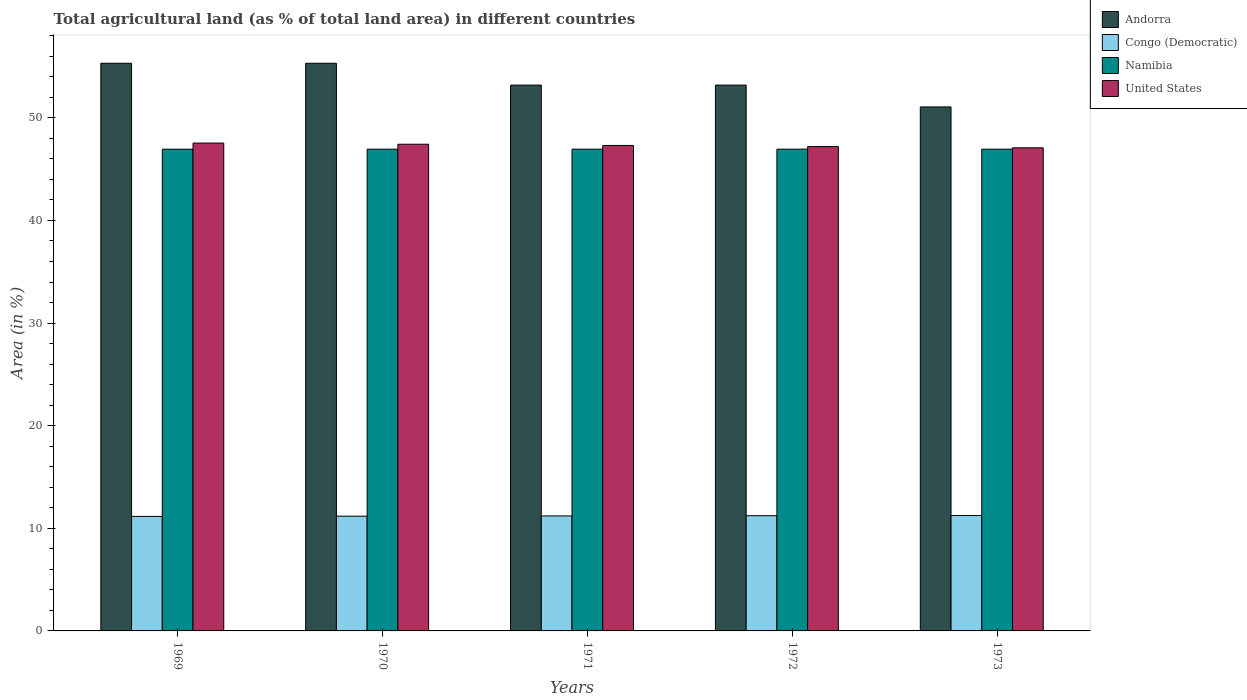How many groups of bars are there?
Your response must be concise. 5. Are the number of bars on each tick of the X-axis equal?
Offer a terse response. Yes. How many bars are there on the 1st tick from the left?
Provide a short and direct response. 4. What is the percentage of agricultural land in Andorra in 1971?
Keep it short and to the point. 53.19. Across all years, what is the maximum percentage of agricultural land in Congo (Democratic)?
Your answer should be compact. 11.25. Across all years, what is the minimum percentage of agricultural land in Congo (Democratic)?
Your answer should be compact. 11.16. In which year was the percentage of agricultural land in Andorra maximum?
Offer a very short reply. 1969. In which year was the percentage of agricultural land in Namibia minimum?
Make the answer very short. 1969. What is the total percentage of agricultural land in Congo (Democratic) in the graph?
Your response must be concise. 56.02. What is the difference between the percentage of agricultural land in Congo (Democratic) in 1969 and that in 1973?
Ensure brevity in your answer.  -0.09. What is the difference between the percentage of agricultural land in United States in 1973 and the percentage of agricultural land in Namibia in 1972?
Offer a very short reply. 0.13. What is the average percentage of agricultural land in Namibia per year?
Your answer should be compact. 46.95. In the year 1972, what is the difference between the percentage of agricultural land in Andorra and percentage of agricultural land in Namibia?
Offer a very short reply. 6.24. What is the ratio of the percentage of agricultural land in Namibia in 1969 to that in 1972?
Provide a succinct answer. 1. Is the difference between the percentage of agricultural land in Andorra in 1969 and 1970 greater than the difference between the percentage of agricultural land in Namibia in 1969 and 1970?
Ensure brevity in your answer.  Yes. What is the difference between the highest and the second highest percentage of agricultural land in United States?
Your response must be concise. 0.11. What is the difference between the highest and the lowest percentage of agricultural land in Andorra?
Offer a very short reply. 4.26. In how many years, is the percentage of agricultural land in United States greater than the average percentage of agricultural land in United States taken over all years?
Give a very brief answer. 2. What does the 1st bar from the left in 1970 represents?
Provide a short and direct response. Andorra. What does the 4th bar from the right in 1969 represents?
Provide a short and direct response. Andorra. Is it the case that in every year, the sum of the percentage of agricultural land in Namibia and percentage of agricultural land in United States is greater than the percentage of agricultural land in Andorra?
Your response must be concise. Yes. How many bars are there?
Provide a short and direct response. 20. Are all the bars in the graph horizontal?
Offer a terse response. No. How many years are there in the graph?
Your answer should be compact. 5. What is the difference between two consecutive major ticks on the Y-axis?
Keep it short and to the point. 10. Are the values on the major ticks of Y-axis written in scientific E-notation?
Your response must be concise. No. Where does the legend appear in the graph?
Keep it short and to the point. Top right. How many legend labels are there?
Offer a very short reply. 4. What is the title of the graph?
Your response must be concise. Total agricultural land (as % of total land area) in different countries. What is the label or title of the Y-axis?
Make the answer very short. Area (in %). What is the Area (in %) of Andorra in 1969?
Your response must be concise. 55.32. What is the Area (in %) in Congo (Democratic) in 1969?
Keep it short and to the point. 11.16. What is the Area (in %) of Namibia in 1969?
Your answer should be very brief. 46.94. What is the Area (in %) in United States in 1969?
Your answer should be very brief. 47.54. What is the Area (in %) in Andorra in 1970?
Your answer should be compact. 55.32. What is the Area (in %) in Congo (Democratic) in 1970?
Your response must be concise. 11.18. What is the Area (in %) of Namibia in 1970?
Keep it short and to the point. 46.95. What is the Area (in %) of United States in 1970?
Your answer should be compact. 47.43. What is the Area (in %) in Andorra in 1971?
Give a very brief answer. 53.19. What is the Area (in %) of Congo (Democratic) in 1971?
Provide a short and direct response. 11.2. What is the Area (in %) in Namibia in 1971?
Provide a succinct answer. 46.95. What is the Area (in %) of United States in 1971?
Make the answer very short. 47.31. What is the Area (in %) in Andorra in 1972?
Ensure brevity in your answer.  53.19. What is the Area (in %) in Congo (Democratic) in 1972?
Offer a very short reply. 11.23. What is the Area (in %) in Namibia in 1972?
Make the answer very short. 46.95. What is the Area (in %) in United States in 1972?
Your response must be concise. 47.2. What is the Area (in %) of Andorra in 1973?
Give a very brief answer. 51.06. What is the Area (in %) in Congo (Democratic) in 1973?
Ensure brevity in your answer.  11.25. What is the Area (in %) in Namibia in 1973?
Offer a very short reply. 46.95. What is the Area (in %) of United States in 1973?
Provide a short and direct response. 47.08. Across all years, what is the maximum Area (in %) in Andorra?
Give a very brief answer. 55.32. Across all years, what is the maximum Area (in %) of Congo (Democratic)?
Offer a terse response. 11.25. Across all years, what is the maximum Area (in %) in Namibia?
Provide a short and direct response. 46.95. Across all years, what is the maximum Area (in %) of United States?
Your answer should be compact. 47.54. Across all years, what is the minimum Area (in %) in Andorra?
Offer a very short reply. 51.06. Across all years, what is the minimum Area (in %) of Congo (Democratic)?
Make the answer very short. 11.16. Across all years, what is the minimum Area (in %) of Namibia?
Your response must be concise. 46.94. Across all years, what is the minimum Area (in %) of United States?
Ensure brevity in your answer.  47.08. What is the total Area (in %) of Andorra in the graph?
Provide a short and direct response. 268.09. What is the total Area (in %) in Congo (Democratic) in the graph?
Offer a very short reply. 56.02. What is the total Area (in %) of Namibia in the graph?
Offer a terse response. 234.74. What is the total Area (in %) of United States in the graph?
Provide a succinct answer. 236.56. What is the difference between the Area (in %) in Congo (Democratic) in 1969 and that in 1970?
Offer a terse response. -0.02. What is the difference between the Area (in %) of Namibia in 1969 and that in 1970?
Your response must be concise. -0. What is the difference between the Area (in %) in United States in 1969 and that in 1970?
Your answer should be very brief. 0.11. What is the difference between the Area (in %) of Andorra in 1969 and that in 1971?
Make the answer very short. 2.13. What is the difference between the Area (in %) of Congo (Democratic) in 1969 and that in 1971?
Offer a terse response. -0.04. What is the difference between the Area (in %) in Namibia in 1969 and that in 1971?
Make the answer very short. -0. What is the difference between the Area (in %) of United States in 1969 and that in 1971?
Offer a very short reply. 0.23. What is the difference between the Area (in %) in Andorra in 1969 and that in 1972?
Your answer should be compact. 2.13. What is the difference between the Area (in %) in Congo (Democratic) in 1969 and that in 1972?
Make the answer very short. -0.07. What is the difference between the Area (in %) in Namibia in 1969 and that in 1972?
Make the answer very short. -0. What is the difference between the Area (in %) of United States in 1969 and that in 1972?
Your answer should be compact. 0.34. What is the difference between the Area (in %) of Andorra in 1969 and that in 1973?
Offer a very short reply. 4.26. What is the difference between the Area (in %) in Congo (Democratic) in 1969 and that in 1973?
Make the answer very short. -0.09. What is the difference between the Area (in %) in Namibia in 1969 and that in 1973?
Your response must be concise. -0. What is the difference between the Area (in %) of United States in 1969 and that in 1973?
Ensure brevity in your answer.  0.46. What is the difference between the Area (in %) in Andorra in 1970 and that in 1971?
Provide a short and direct response. 2.13. What is the difference between the Area (in %) of Congo (Democratic) in 1970 and that in 1971?
Provide a short and direct response. -0.02. What is the difference between the Area (in %) of Namibia in 1970 and that in 1971?
Provide a short and direct response. -0. What is the difference between the Area (in %) of United States in 1970 and that in 1971?
Ensure brevity in your answer.  0.12. What is the difference between the Area (in %) in Andorra in 1970 and that in 1972?
Offer a terse response. 2.13. What is the difference between the Area (in %) of Congo (Democratic) in 1970 and that in 1972?
Your answer should be very brief. -0.04. What is the difference between the Area (in %) of Namibia in 1970 and that in 1972?
Your response must be concise. -0. What is the difference between the Area (in %) of United States in 1970 and that in 1972?
Provide a short and direct response. 0.23. What is the difference between the Area (in %) in Andorra in 1970 and that in 1973?
Your response must be concise. 4.26. What is the difference between the Area (in %) of Congo (Democratic) in 1970 and that in 1973?
Keep it short and to the point. -0.07. What is the difference between the Area (in %) of Namibia in 1970 and that in 1973?
Your answer should be compact. -0. What is the difference between the Area (in %) of United States in 1970 and that in 1973?
Give a very brief answer. 0.35. What is the difference between the Area (in %) in Congo (Democratic) in 1971 and that in 1972?
Provide a succinct answer. -0.02. What is the difference between the Area (in %) in Namibia in 1971 and that in 1972?
Keep it short and to the point. 0. What is the difference between the Area (in %) in United States in 1971 and that in 1972?
Ensure brevity in your answer.  0.11. What is the difference between the Area (in %) in Andorra in 1971 and that in 1973?
Make the answer very short. 2.13. What is the difference between the Area (in %) of Congo (Democratic) in 1971 and that in 1973?
Make the answer very short. -0.04. What is the difference between the Area (in %) of United States in 1971 and that in 1973?
Offer a terse response. 0.23. What is the difference between the Area (in %) in Andorra in 1972 and that in 1973?
Keep it short and to the point. 2.13. What is the difference between the Area (in %) in Congo (Democratic) in 1972 and that in 1973?
Your answer should be compact. -0.02. What is the difference between the Area (in %) in United States in 1972 and that in 1973?
Ensure brevity in your answer.  0.12. What is the difference between the Area (in %) in Andorra in 1969 and the Area (in %) in Congo (Democratic) in 1970?
Your answer should be compact. 44.14. What is the difference between the Area (in %) of Andorra in 1969 and the Area (in %) of Namibia in 1970?
Offer a terse response. 8.37. What is the difference between the Area (in %) of Andorra in 1969 and the Area (in %) of United States in 1970?
Provide a succinct answer. 7.89. What is the difference between the Area (in %) of Congo (Democratic) in 1969 and the Area (in %) of Namibia in 1970?
Offer a terse response. -35.79. What is the difference between the Area (in %) of Congo (Democratic) in 1969 and the Area (in %) of United States in 1970?
Ensure brevity in your answer.  -36.27. What is the difference between the Area (in %) in Namibia in 1969 and the Area (in %) in United States in 1970?
Make the answer very short. -0.48. What is the difference between the Area (in %) in Andorra in 1969 and the Area (in %) in Congo (Democratic) in 1971?
Give a very brief answer. 44.12. What is the difference between the Area (in %) in Andorra in 1969 and the Area (in %) in Namibia in 1971?
Offer a very short reply. 8.37. What is the difference between the Area (in %) of Andorra in 1969 and the Area (in %) of United States in 1971?
Provide a short and direct response. 8.01. What is the difference between the Area (in %) of Congo (Democratic) in 1969 and the Area (in %) of Namibia in 1971?
Give a very brief answer. -35.79. What is the difference between the Area (in %) of Congo (Democratic) in 1969 and the Area (in %) of United States in 1971?
Provide a short and direct response. -36.15. What is the difference between the Area (in %) of Namibia in 1969 and the Area (in %) of United States in 1971?
Give a very brief answer. -0.36. What is the difference between the Area (in %) in Andorra in 1969 and the Area (in %) in Congo (Democratic) in 1972?
Provide a succinct answer. 44.09. What is the difference between the Area (in %) in Andorra in 1969 and the Area (in %) in Namibia in 1972?
Keep it short and to the point. 8.37. What is the difference between the Area (in %) of Andorra in 1969 and the Area (in %) of United States in 1972?
Offer a very short reply. 8.12. What is the difference between the Area (in %) of Congo (Democratic) in 1969 and the Area (in %) of Namibia in 1972?
Make the answer very short. -35.79. What is the difference between the Area (in %) in Congo (Democratic) in 1969 and the Area (in %) in United States in 1972?
Your answer should be compact. -36.04. What is the difference between the Area (in %) of Namibia in 1969 and the Area (in %) of United States in 1972?
Give a very brief answer. -0.26. What is the difference between the Area (in %) of Andorra in 1969 and the Area (in %) of Congo (Democratic) in 1973?
Your answer should be compact. 44.07. What is the difference between the Area (in %) of Andorra in 1969 and the Area (in %) of Namibia in 1973?
Provide a short and direct response. 8.37. What is the difference between the Area (in %) in Andorra in 1969 and the Area (in %) in United States in 1973?
Make the answer very short. 8.24. What is the difference between the Area (in %) of Congo (Democratic) in 1969 and the Area (in %) of Namibia in 1973?
Give a very brief answer. -35.79. What is the difference between the Area (in %) in Congo (Democratic) in 1969 and the Area (in %) in United States in 1973?
Ensure brevity in your answer.  -35.92. What is the difference between the Area (in %) in Namibia in 1969 and the Area (in %) in United States in 1973?
Provide a succinct answer. -0.14. What is the difference between the Area (in %) of Andorra in 1970 and the Area (in %) of Congo (Democratic) in 1971?
Give a very brief answer. 44.12. What is the difference between the Area (in %) of Andorra in 1970 and the Area (in %) of Namibia in 1971?
Provide a succinct answer. 8.37. What is the difference between the Area (in %) in Andorra in 1970 and the Area (in %) in United States in 1971?
Offer a terse response. 8.01. What is the difference between the Area (in %) of Congo (Democratic) in 1970 and the Area (in %) of Namibia in 1971?
Your answer should be very brief. -35.77. What is the difference between the Area (in %) of Congo (Democratic) in 1970 and the Area (in %) of United States in 1971?
Ensure brevity in your answer.  -36.13. What is the difference between the Area (in %) in Namibia in 1970 and the Area (in %) in United States in 1971?
Keep it short and to the point. -0.36. What is the difference between the Area (in %) in Andorra in 1970 and the Area (in %) in Congo (Democratic) in 1972?
Offer a terse response. 44.09. What is the difference between the Area (in %) of Andorra in 1970 and the Area (in %) of Namibia in 1972?
Your answer should be very brief. 8.37. What is the difference between the Area (in %) of Andorra in 1970 and the Area (in %) of United States in 1972?
Ensure brevity in your answer.  8.12. What is the difference between the Area (in %) in Congo (Democratic) in 1970 and the Area (in %) in Namibia in 1972?
Give a very brief answer. -35.77. What is the difference between the Area (in %) of Congo (Democratic) in 1970 and the Area (in %) of United States in 1972?
Your answer should be very brief. -36.02. What is the difference between the Area (in %) of Namibia in 1970 and the Area (in %) of United States in 1972?
Provide a short and direct response. -0.25. What is the difference between the Area (in %) in Andorra in 1970 and the Area (in %) in Congo (Democratic) in 1973?
Your answer should be very brief. 44.07. What is the difference between the Area (in %) in Andorra in 1970 and the Area (in %) in Namibia in 1973?
Make the answer very short. 8.37. What is the difference between the Area (in %) of Andorra in 1970 and the Area (in %) of United States in 1973?
Give a very brief answer. 8.24. What is the difference between the Area (in %) in Congo (Democratic) in 1970 and the Area (in %) in Namibia in 1973?
Provide a short and direct response. -35.77. What is the difference between the Area (in %) of Congo (Democratic) in 1970 and the Area (in %) of United States in 1973?
Make the answer very short. -35.9. What is the difference between the Area (in %) in Namibia in 1970 and the Area (in %) in United States in 1973?
Your answer should be compact. -0.13. What is the difference between the Area (in %) of Andorra in 1971 and the Area (in %) of Congo (Democratic) in 1972?
Your answer should be very brief. 41.97. What is the difference between the Area (in %) of Andorra in 1971 and the Area (in %) of Namibia in 1972?
Offer a very short reply. 6.24. What is the difference between the Area (in %) in Andorra in 1971 and the Area (in %) in United States in 1972?
Your response must be concise. 5.99. What is the difference between the Area (in %) of Congo (Democratic) in 1971 and the Area (in %) of Namibia in 1972?
Offer a very short reply. -35.75. What is the difference between the Area (in %) in Congo (Democratic) in 1971 and the Area (in %) in United States in 1972?
Give a very brief answer. -36. What is the difference between the Area (in %) in Namibia in 1971 and the Area (in %) in United States in 1972?
Provide a short and direct response. -0.25. What is the difference between the Area (in %) in Andorra in 1971 and the Area (in %) in Congo (Democratic) in 1973?
Your answer should be very brief. 41.94. What is the difference between the Area (in %) of Andorra in 1971 and the Area (in %) of Namibia in 1973?
Offer a very short reply. 6.24. What is the difference between the Area (in %) of Andorra in 1971 and the Area (in %) of United States in 1973?
Your answer should be compact. 6.11. What is the difference between the Area (in %) of Congo (Democratic) in 1971 and the Area (in %) of Namibia in 1973?
Your answer should be very brief. -35.75. What is the difference between the Area (in %) of Congo (Democratic) in 1971 and the Area (in %) of United States in 1973?
Ensure brevity in your answer.  -35.88. What is the difference between the Area (in %) in Namibia in 1971 and the Area (in %) in United States in 1973?
Offer a very short reply. -0.13. What is the difference between the Area (in %) in Andorra in 1972 and the Area (in %) in Congo (Democratic) in 1973?
Offer a very short reply. 41.94. What is the difference between the Area (in %) in Andorra in 1972 and the Area (in %) in Namibia in 1973?
Offer a very short reply. 6.24. What is the difference between the Area (in %) of Andorra in 1972 and the Area (in %) of United States in 1973?
Make the answer very short. 6.11. What is the difference between the Area (in %) of Congo (Democratic) in 1972 and the Area (in %) of Namibia in 1973?
Ensure brevity in your answer.  -35.72. What is the difference between the Area (in %) of Congo (Democratic) in 1972 and the Area (in %) of United States in 1973?
Offer a terse response. -35.85. What is the difference between the Area (in %) in Namibia in 1972 and the Area (in %) in United States in 1973?
Offer a terse response. -0.13. What is the average Area (in %) in Andorra per year?
Offer a terse response. 53.62. What is the average Area (in %) of Congo (Democratic) per year?
Provide a short and direct response. 11.2. What is the average Area (in %) of Namibia per year?
Make the answer very short. 46.95. What is the average Area (in %) of United States per year?
Offer a terse response. 47.31. In the year 1969, what is the difference between the Area (in %) of Andorra and Area (in %) of Congo (Democratic)?
Offer a very short reply. 44.16. In the year 1969, what is the difference between the Area (in %) in Andorra and Area (in %) in Namibia?
Make the answer very short. 8.37. In the year 1969, what is the difference between the Area (in %) of Andorra and Area (in %) of United States?
Your answer should be very brief. 7.78. In the year 1969, what is the difference between the Area (in %) of Congo (Democratic) and Area (in %) of Namibia?
Make the answer very short. -35.78. In the year 1969, what is the difference between the Area (in %) of Congo (Democratic) and Area (in %) of United States?
Your response must be concise. -36.38. In the year 1969, what is the difference between the Area (in %) in Namibia and Area (in %) in United States?
Your answer should be very brief. -0.6. In the year 1970, what is the difference between the Area (in %) in Andorra and Area (in %) in Congo (Democratic)?
Keep it short and to the point. 44.14. In the year 1970, what is the difference between the Area (in %) of Andorra and Area (in %) of Namibia?
Your response must be concise. 8.37. In the year 1970, what is the difference between the Area (in %) of Andorra and Area (in %) of United States?
Your response must be concise. 7.89. In the year 1970, what is the difference between the Area (in %) of Congo (Democratic) and Area (in %) of Namibia?
Provide a succinct answer. -35.77. In the year 1970, what is the difference between the Area (in %) in Congo (Democratic) and Area (in %) in United States?
Give a very brief answer. -36.25. In the year 1970, what is the difference between the Area (in %) in Namibia and Area (in %) in United States?
Provide a short and direct response. -0.48. In the year 1971, what is the difference between the Area (in %) of Andorra and Area (in %) of Congo (Democratic)?
Provide a succinct answer. 41.99. In the year 1971, what is the difference between the Area (in %) of Andorra and Area (in %) of Namibia?
Your response must be concise. 6.24. In the year 1971, what is the difference between the Area (in %) in Andorra and Area (in %) in United States?
Offer a terse response. 5.88. In the year 1971, what is the difference between the Area (in %) of Congo (Democratic) and Area (in %) of Namibia?
Keep it short and to the point. -35.75. In the year 1971, what is the difference between the Area (in %) of Congo (Democratic) and Area (in %) of United States?
Provide a succinct answer. -36.1. In the year 1971, what is the difference between the Area (in %) of Namibia and Area (in %) of United States?
Offer a very short reply. -0.36. In the year 1972, what is the difference between the Area (in %) in Andorra and Area (in %) in Congo (Democratic)?
Provide a short and direct response. 41.97. In the year 1972, what is the difference between the Area (in %) of Andorra and Area (in %) of Namibia?
Your response must be concise. 6.24. In the year 1972, what is the difference between the Area (in %) of Andorra and Area (in %) of United States?
Provide a succinct answer. 5.99. In the year 1972, what is the difference between the Area (in %) of Congo (Democratic) and Area (in %) of Namibia?
Provide a succinct answer. -35.72. In the year 1972, what is the difference between the Area (in %) in Congo (Democratic) and Area (in %) in United States?
Your response must be concise. -35.97. In the year 1972, what is the difference between the Area (in %) in Namibia and Area (in %) in United States?
Give a very brief answer. -0.25. In the year 1973, what is the difference between the Area (in %) of Andorra and Area (in %) of Congo (Democratic)?
Your response must be concise. 39.82. In the year 1973, what is the difference between the Area (in %) in Andorra and Area (in %) in Namibia?
Offer a very short reply. 4.11. In the year 1973, what is the difference between the Area (in %) of Andorra and Area (in %) of United States?
Give a very brief answer. 3.98. In the year 1973, what is the difference between the Area (in %) in Congo (Democratic) and Area (in %) in Namibia?
Your response must be concise. -35.7. In the year 1973, what is the difference between the Area (in %) in Congo (Democratic) and Area (in %) in United States?
Keep it short and to the point. -35.83. In the year 1973, what is the difference between the Area (in %) of Namibia and Area (in %) of United States?
Give a very brief answer. -0.13. What is the ratio of the Area (in %) in Congo (Democratic) in 1969 to that in 1970?
Ensure brevity in your answer.  1. What is the ratio of the Area (in %) in Andorra in 1969 to that in 1971?
Your answer should be compact. 1.04. What is the ratio of the Area (in %) in Andorra in 1969 to that in 1972?
Your response must be concise. 1.04. What is the ratio of the Area (in %) in Congo (Democratic) in 1969 to that in 1972?
Ensure brevity in your answer.  0.99. What is the ratio of the Area (in %) of United States in 1969 to that in 1972?
Give a very brief answer. 1.01. What is the ratio of the Area (in %) of Congo (Democratic) in 1969 to that in 1973?
Provide a succinct answer. 0.99. What is the ratio of the Area (in %) of United States in 1969 to that in 1973?
Provide a succinct answer. 1.01. What is the ratio of the Area (in %) of Congo (Democratic) in 1970 to that in 1971?
Your response must be concise. 1. What is the ratio of the Area (in %) of Andorra in 1970 to that in 1972?
Offer a terse response. 1.04. What is the ratio of the Area (in %) in Namibia in 1970 to that in 1972?
Your answer should be compact. 1. What is the ratio of the Area (in %) in Andorra in 1970 to that in 1973?
Offer a very short reply. 1.08. What is the ratio of the Area (in %) of Namibia in 1970 to that in 1973?
Provide a short and direct response. 1. What is the ratio of the Area (in %) in United States in 1970 to that in 1973?
Provide a short and direct response. 1.01. What is the ratio of the Area (in %) of Namibia in 1971 to that in 1972?
Give a very brief answer. 1. What is the ratio of the Area (in %) in United States in 1971 to that in 1972?
Your answer should be compact. 1. What is the ratio of the Area (in %) of Andorra in 1971 to that in 1973?
Offer a terse response. 1.04. What is the ratio of the Area (in %) in Congo (Democratic) in 1971 to that in 1973?
Provide a short and direct response. 1. What is the ratio of the Area (in %) of Andorra in 1972 to that in 1973?
Give a very brief answer. 1.04. What is the ratio of the Area (in %) of Congo (Democratic) in 1972 to that in 1973?
Your response must be concise. 1. What is the difference between the highest and the second highest Area (in %) of Andorra?
Your response must be concise. 0. What is the difference between the highest and the second highest Area (in %) in Congo (Democratic)?
Your response must be concise. 0.02. What is the difference between the highest and the second highest Area (in %) of United States?
Your response must be concise. 0.11. What is the difference between the highest and the lowest Area (in %) in Andorra?
Keep it short and to the point. 4.26. What is the difference between the highest and the lowest Area (in %) in Congo (Democratic)?
Ensure brevity in your answer.  0.09. What is the difference between the highest and the lowest Area (in %) in Namibia?
Provide a succinct answer. 0. What is the difference between the highest and the lowest Area (in %) of United States?
Offer a terse response. 0.46. 